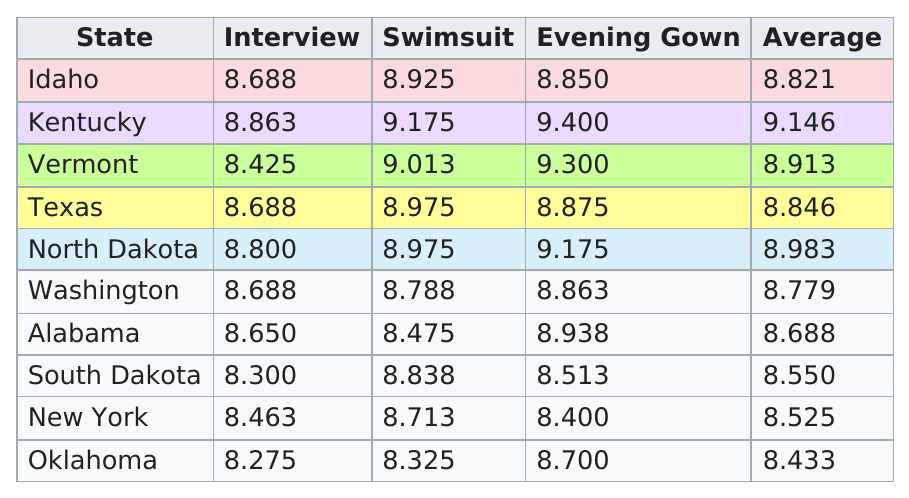Point out several critical features in this image. Idaho was the state that placed first in the 1989 Miss Teen USA competition. Kentucky has the highest amount of swimsuits. There is at least one state that has an average IQ score under 8.5. Out of the four scores, the average score was below 8.700. Kentucky had the most points in the swimsuit competition. 